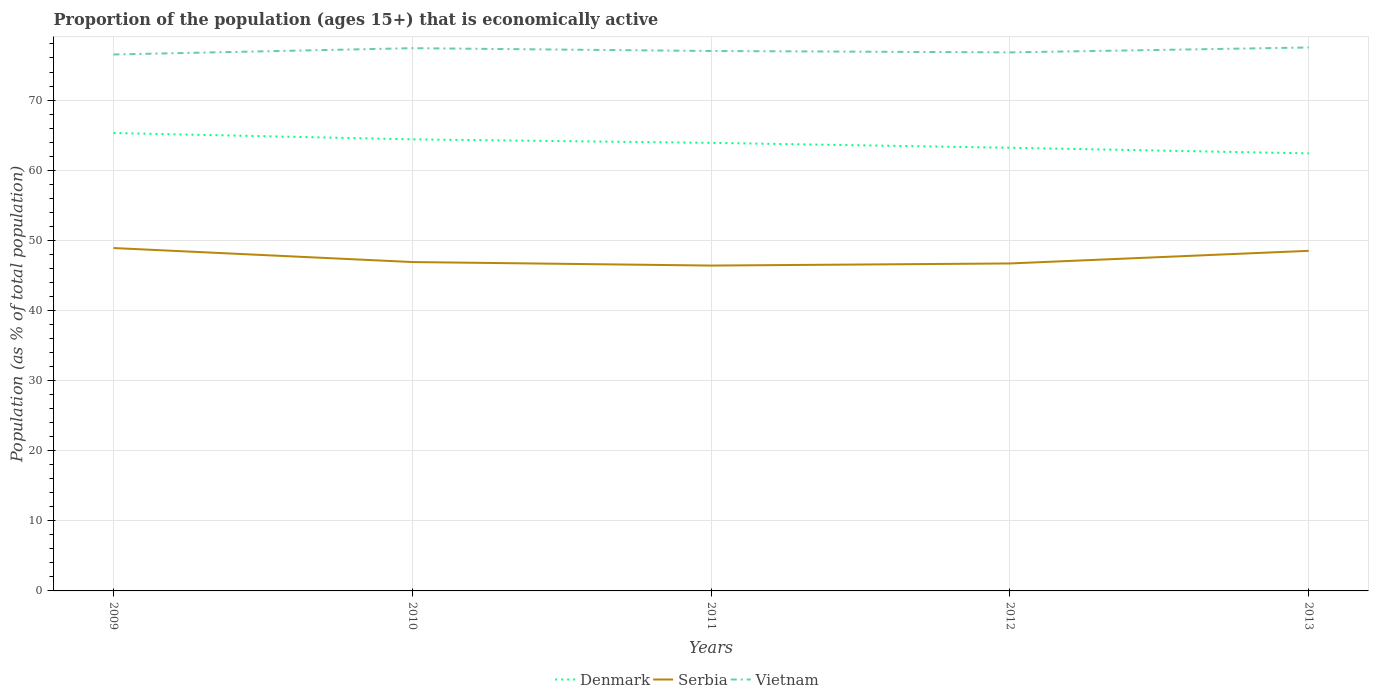How many different coloured lines are there?
Provide a succinct answer. 3. Is the number of lines equal to the number of legend labels?
Keep it short and to the point. Yes. Across all years, what is the maximum proportion of the population that is economically active in Vietnam?
Ensure brevity in your answer.  76.5. In which year was the proportion of the population that is economically active in Serbia maximum?
Ensure brevity in your answer.  2011. What is the total proportion of the population that is economically active in Vietnam in the graph?
Your response must be concise. -1. Are the values on the major ticks of Y-axis written in scientific E-notation?
Provide a short and direct response. No. Where does the legend appear in the graph?
Keep it short and to the point. Bottom center. How many legend labels are there?
Provide a succinct answer. 3. How are the legend labels stacked?
Provide a short and direct response. Horizontal. What is the title of the graph?
Your answer should be very brief. Proportion of the population (ages 15+) that is economically active. Does "United States" appear as one of the legend labels in the graph?
Offer a terse response. No. What is the label or title of the Y-axis?
Give a very brief answer. Population (as % of total population). What is the Population (as % of total population) in Denmark in 2009?
Provide a short and direct response. 65.3. What is the Population (as % of total population) of Serbia in 2009?
Provide a short and direct response. 48.9. What is the Population (as % of total population) in Vietnam in 2009?
Your response must be concise. 76.5. What is the Population (as % of total population) of Denmark in 2010?
Offer a very short reply. 64.4. What is the Population (as % of total population) of Serbia in 2010?
Give a very brief answer. 46.9. What is the Population (as % of total population) of Vietnam in 2010?
Make the answer very short. 77.4. What is the Population (as % of total population) in Denmark in 2011?
Your answer should be very brief. 63.9. What is the Population (as % of total population) in Serbia in 2011?
Give a very brief answer. 46.4. What is the Population (as % of total population) of Vietnam in 2011?
Offer a terse response. 77. What is the Population (as % of total population) of Denmark in 2012?
Give a very brief answer. 63.2. What is the Population (as % of total population) of Serbia in 2012?
Offer a very short reply. 46.7. What is the Population (as % of total population) in Vietnam in 2012?
Keep it short and to the point. 76.8. What is the Population (as % of total population) in Denmark in 2013?
Provide a short and direct response. 62.4. What is the Population (as % of total population) of Serbia in 2013?
Ensure brevity in your answer.  48.5. What is the Population (as % of total population) in Vietnam in 2013?
Your answer should be very brief. 77.5. Across all years, what is the maximum Population (as % of total population) in Denmark?
Offer a terse response. 65.3. Across all years, what is the maximum Population (as % of total population) of Serbia?
Offer a terse response. 48.9. Across all years, what is the maximum Population (as % of total population) of Vietnam?
Make the answer very short. 77.5. Across all years, what is the minimum Population (as % of total population) of Denmark?
Your response must be concise. 62.4. Across all years, what is the minimum Population (as % of total population) in Serbia?
Your answer should be very brief. 46.4. Across all years, what is the minimum Population (as % of total population) in Vietnam?
Your answer should be compact. 76.5. What is the total Population (as % of total population) in Denmark in the graph?
Offer a terse response. 319.2. What is the total Population (as % of total population) in Serbia in the graph?
Make the answer very short. 237.4. What is the total Population (as % of total population) in Vietnam in the graph?
Your answer should be very brief. 385.2. What is the difference between the Population (as % of total population) in Serbia in 2009 and that in 2010?
Your answer should be compact. 2. What is the difference between the Population (as % of total population) of Vietnam in 2009 and that in 2010?
Your response must be concise. -0.9. What is the difference between the Population (as % of total population) of Serbia in 2009 and that in 2011?
Provide a short and direct response. 2.5. What is the difference between the Population (as % of total population) of Serbia in 2009 and that in 2012?
Give a very brief answer. 2.2. What is the difference between the Population (as % of total population) of Denmark in 2009 and that in 2013?
Give a very brief answer. 2.9. What is the difference between the Population (as % of total population) of Vietnam in 2009 and that in 2013?
Your answer should be compact. -1. What is the difference between the Population (as % of total population) in Serbia in 2010 and that in 2011?
Your response must be concise. 0.5. What is the difference between the Population (as % of total population) of Denmark in 2010 and that in 2012?
Give a very brief answer. 1.2. What is the difference between the Population (as % of total population) in Serbia in 2010 and that in 2013?
Provide a short and direct response. -1.6. What is the difference between the Population (as % of total population) in Denmark in 2011 and that in 2012?
Offer a very short reply. 0.7. What is the difference between the Population (as % of total population) in Vietnam in 2011 and that in 2012?
Your answer should be compact. 0.2. What is the difference between the Population (as % of total population) of Denmark in 2011 and that in 2013?
Your answer should be compact. 1.5. What is the difference between the Population (as % of total population) of Serbia in 2011 and that in 2013?
Offer a very short reply. -2.1. What is the difference between the Population (as % of total population) in Vietnam in 2011 and that in 2013?
Offer a very short reply. -0.5. What is the difference between the Population (as % of total population) in Serbia in 2012 and that in 2013?
Provide a succinct answer. -1.8. What is the difference between the Population (as % of total population) of Vietnam in 2012 and that in 2013?
Your response must be concise. -0.7. What is the difference between the Population (as % of total population) of Denmark in 2009 and the Population (as % of total population) of Serbia in 2010?
Provide a succinct answer. 18.4. What is the difference between the Population (as % of total population) in Denmark in 2009 and the Population (as % of total population) in Vietnam in 2010?
Your answer should be compact. -12.1. What is the difference between the Population (as % of total population) of Serbia in 2009 and the Population (as % of total population) of Vietnam in 2010?
Your answer should be compact. -28.5. What is the difference between the Population (as % of total population) of Denmark in 2009 and the Population (as % of total population) of Vietnam in 2011?
Your response must be concise. -11.7. What is the difference between the Population (as % of total population) in Serbia in 2009 and the Population (as % of total population) in Vietnam in 2011?
Offer a very short reply. -28.1. What is the difference between the Population (as % of total population) of Serbia in 2009 and the Population (as % of total population) of Vietnam in 2012?
Your answer should be compact. -27.9. What is the difference between the Population (as % of total population) in Denmark in 2009 and the Population (as % of total population) in Serbia in 2013?
Make the answer very short. 16.8. What is the difference between the Population (as % of total population) of Denmark in 2009 and the Population (as % of total population) of Vietnam in 2013?
Make the answer very short. -12.2. What is the difference between the Population (as % of total population) in Serbia in 2009 and the Population (as % of total population) in Vietnam in 2013?
Offer a very short reply. -28.6. What is the difference between the Population (as % of total population) in Denmark in 2010 and the Population (as % of total population) in Vietnam in 2011?
Give a very brief answer. -12.6. What is the difference between the Population (as % of total population) in Serbia in 2010 and the Population (as % of total population) in Vietnam in 2011?
Your answer should be compact. -30.1. What is the difference between the Population (as % of total population) of Serbia in 2010 and the Population (as % of total population) of Vietnam in 2012?
Your answer should be compact. -29.9. What is the difference between the Population (as % of total population) in Denmark in 2010 and the Population (as % of total population) in Vietnam in 2013?
Your response must be concise. -13.1. What is the difference between the Population (as % of total population) in Serbia in 2010 and the Population (as % of total population) in Vietnam in 2013?
Your answer should be compact. -30.6. What is the difference between the Population (as % of total population) of Serbia in 2011 and the Population (as % of total population) of Vietnam in 2012?
Provide a succinct answer. -30.4. What is the difference between the Population (as % of total population) in Serbia in 2011 and the Population (as % of total population) in Vietnam in 2013?
Make the answer very short. -31.1. What is the difference between the Population (as % of total population) in Denmark in 2012 and the Population (as % of total population) in Vietnam in 2013?
Give a very brief answer. -14.3. What is the difference between the Population (as % of total population) in Serbia in 2012 and the Population (as % of total population) in Vietnam in 2013?
Offer a very short reply. -30.8. What is the average Population (as % of total population) in Denmark per year?
Provide a succinct answer. 63.84. What is the average Population (as % of total population) in Serbia per year?
Provide a short and direct response. 47.48. What is the average Population (as % of total population) of Vietnam per year?
Your answer should be compact. 77.04. In the year 2009, what is the difference between the Population (as % of total population) in Denmark and Population (as % of total population) in Vietnam?
Give a very brief answer. -11.2. In the year 2009, what is the difference between the Population (as % of total population) of Serbia and Population (as % of total population) of Vietnam?
Your answer should be compact. -27.6. In the year 2010, what is the difference between the Population (as % of total population) of Denmark and Population (as % of total population) of Serbia?
Provide a succinct answer. 17.5. In the year 2010, what is the difference between the Population (as % of total population) in Denmark and Population (as % of total population) in Vietnam?
Your response must be concise. -13. In the year 2010, what is the difference between the Population (as % of total population) in Serbia and Population (as % of total population) in Vietnam?
Ensure brevity in your answer.  -30.5. In the year 2011, what is the difference between the Population (as % of total population) of Serbia and Population (as % of total population) of Vietnam?
Provide a short and direct response. -30.6. In the year 2012, what is the difference between the Population (as % of total population) of Denmark and Population (as % of total population) of Vietnam?
Give a very brief answer. -13.6. In the year 2012, what is the difference between the Population (as % of total population) in Serbia and Population (as % of total population) in Vietnam?
Keep it short and to the point. -30.1. In the year 2013, what is the difference between the Population (as % of total population) of Denmark and Population (as % of total population) of Serbia?
Your answer should be compact. 13.9. In the year 2013, what is the difference between the Population (as % of total population) of Denmark and Population (as % of total population) of Vietnam?
Keep it short and to the point. -15.1. In the year 2013, what is the difference between the Population (as % of total population) in Serbia and Population (as % of total population) in Vietnam?
Your answer should be compact. -29. What is the ratio of the Population (as % of total population) in Serbia in 2009 to that in 2010?
Offer a very short reply. 1.04. What is the ratio of the Population (as % of total population) in Vietnam in 2009 to that in 2010?
Offer a terse response. 0.99. What is the ratio of the Population (as % of total population) in Denmark in 2009 to that in 2011?
Keep it short and to the point. 1.02. What is the ratio of the Population (as % of total population) of Serbia in 2009 to that in 2011?
Offer a terse response. 1.05. What is the ratio of the Population (as % of total population) of Vietnam in 2009 to that in 2011?
Keep it short and to the point. 0.99. What is the ratio of the Population (as % of total population) of Denmark in 2009 to that in 2012?
Give a very brief answer. 1.03. What is the ratio of the Population (as % of total population) in Serbia in 2009 to that in 2012?
Provide a succinct answer. 1.05. What is the ratio of the Population (as % of total population) in Vietnam in 2009 to that in 2012?
Ensure brevity in your answer.  1. What is the ratio of the Population (as % of total population) of Denmark in 2009 to that in 2013?
Your answer should be compact. 1.05. What is the ratio of the Population (as % of total population) of Serbia in 2009 to that in 2013?
Offer a very short reply. 1.01. What is the ratio of the Population (as % of total population) in Vietnam in 2009 to that in 2013?
Your answer should be very brief. 0.99. What is the ratio of the Population (as % of total population) of Denmark in 2010 to that in 2011?
Offer a very short reply. 1.01. What is the ratio of the Population (as % of total population) of Serbia in 2010 to that in 2011?
Your answer should be compact. 1.01. What is the ratio of the Population (as % of total population) in Vietnam in 2010 to that in 2011?
Your answer should be compact. 1.01. What is the ratio of the Population (as % of total population) of Vietnam in 2010 to that in 2012?
Your response must be concise. 1.01. What is the ratio of the Population (as % of total population) in Denmark in 2010 to that in 2013?
Offer a very short reply. 1.03. What is the ratio of the Population (as % of total population) in Serbia in 2010 to that in 2013?
Give a very brief answer. 0.97. What is the ratio of the Population (as % of total population) of Denmark in 2011 to that in 2012?
Your answer should be compact. 1.01. What is the ratio of the Population (as % of total population) of Serbia in 2011 to that in 2012?
Give a very brief answer. 0.99. What is the ratio of the Population (as % of total population) of Vietnam in 2011 to that in 2012?
Provide a short and direct response. 1. What is the ratio of the Population (as % of total population) of Serbia in 2011 to that in 2013?
Give a very brief answer. 0.96. What is the ratio of the Population (as % of total population) of Denmark in 2012 to that in 2013?
Provide a short and direct response. 1.01. What is the ratio of the Population (as % of total population) of Serbia in 2012 to that in 2013?
Offer a terse response. 0.96. What is the difference between the highest and the second highest Population (as % of total population) of Denmark?
Keep it short and to the point. 0.9. What is the difference between the highest and the second highest Population (as % of total population) of Vietnam?
Your answer should be compact. 0.1. What is the difference between the highest and the lowest Population (as % of total population) in Denmark?
Your answer should be compact. 2.9. What is the difference between the highest and the lowest Population (as % of total population) in Vietnam?
Provide a short and direct response. 1. 